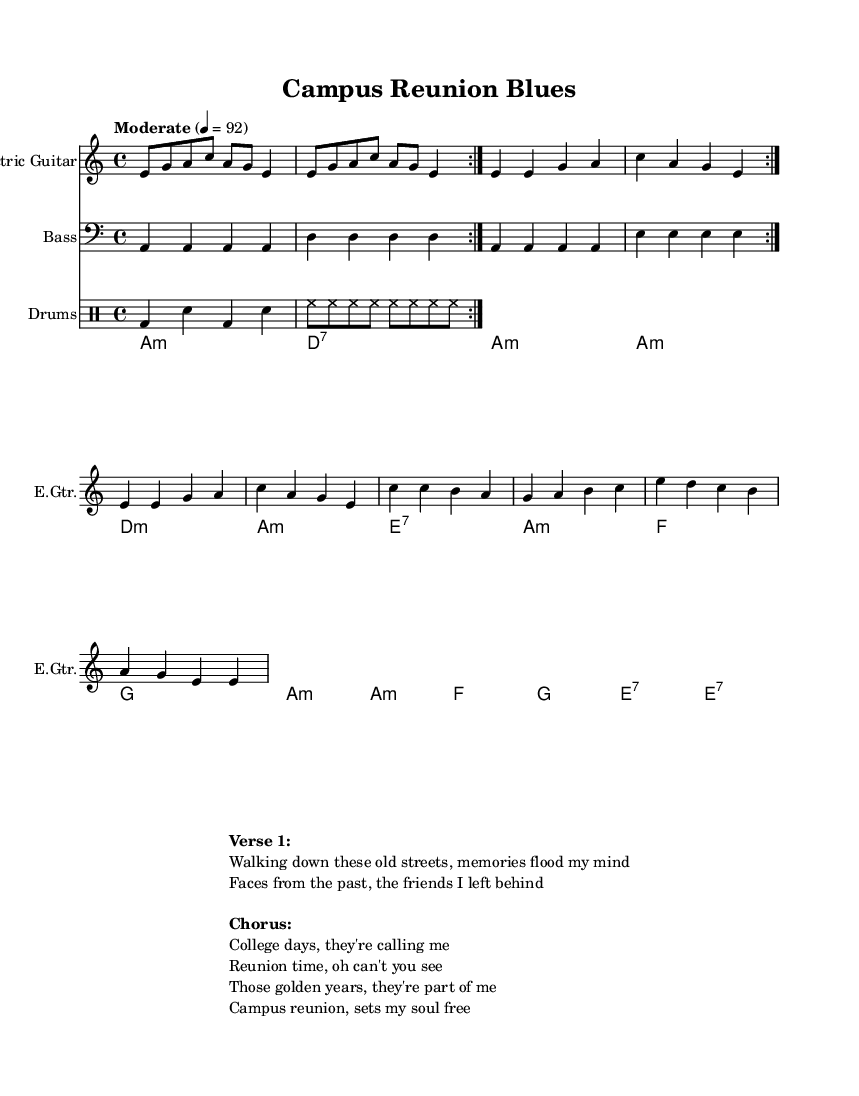What is the key signature of this piece? The key signature is A minor, which has no sharps or flats. This can be deduced from the key indication at the beginning of the score, which shows "a" for A minor.
Answer: A minor What is the time signature of this piece? The time signature is 4/4, indicated at the beginning of the score. This means there are four beats per measure and the quarter note gets one beat.
Answer: 4/4 What is the tempo marking for this piece? The tempo marking is "Moderate" set at 4 = 92. This indicates that the music should be played at a moderate speed with a metronome marking of 92 beats per minute.
Answer: Moderate 4 = 92 How many measures are in the electric guitar part? The electric guitar part contains 12 measures. Counting the repeated volta and the measures in each section leads to a total of 12 distinct measures.
Answer: 12 What type of chord is used in the first measure of the Hammond organ? The first measure contains an A minor chord. This is derived from the chord notation presented in the Hammond organ staff, where "a1:m" indicates an A minor chord.
Answer: A minor What is the primary theme expressed in the lyrics? The primary theme expressed in the lyrics revolves around nostalgia for college days and friendships. The lines talk about memories and the emotional connection to the past.
Answer: Nostalgia for college friendships What style of music is this piece categorized under? This piece is categorized under Electric Blues, as noted in the context of its musical elements and structure. Electric Blues typically involves emotional themes and a focus on electric guitar instrumentation, which is evident here.
Answer: Electric Blues 